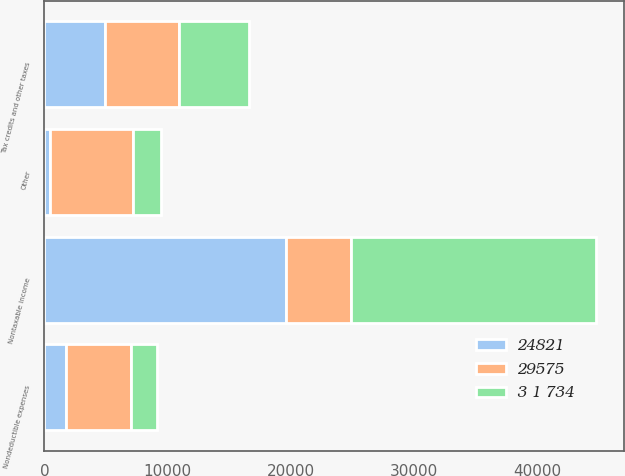Convert chart. <chart><loc_0><loc_0><loc_500><loc_500><stacked_bar_chart><ecel><fcel>Nondeductible expenses<fcel>Nontaxable income<fcel>Tax credits and other taxes<fcel>Other<nl><fcel>29575<fcel>5299<fcel>5299<fcel>5999<fcel>6702<nl><fcel>3 1 734<fcel>2138<fcel>19905<fcel>5722<fcel>2328<nl><fcel>24821<fcel>1714<fcel>19595<fcel>4902<fcel>449<nl></chart> 